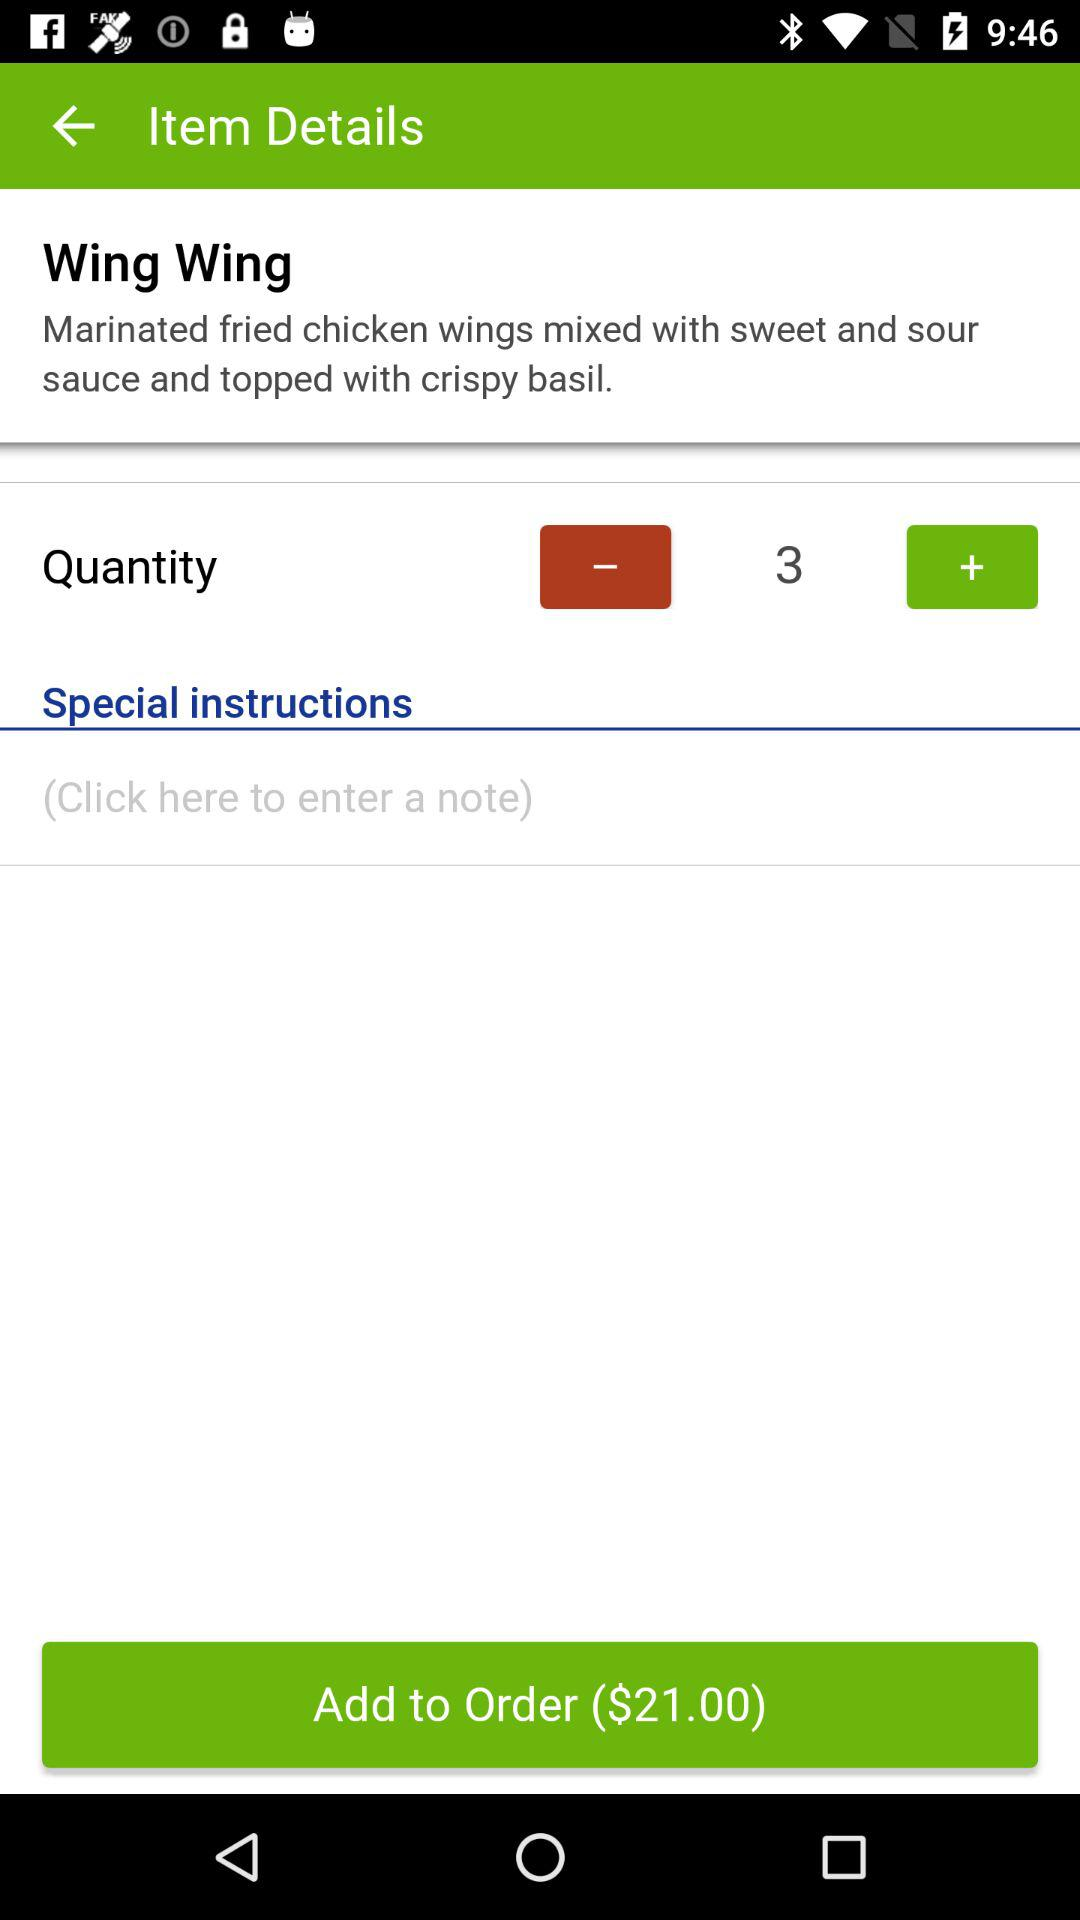What is the price of the order? The price of the order is $21.00. 